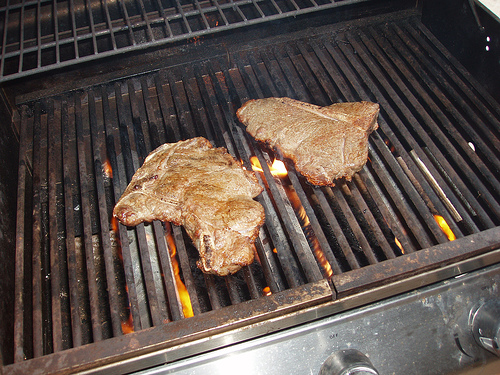<image>
Can you confirm if the steak is above the fire? Yes. The steak is positioned above the fire in the vertical space, higher up in the scene. 